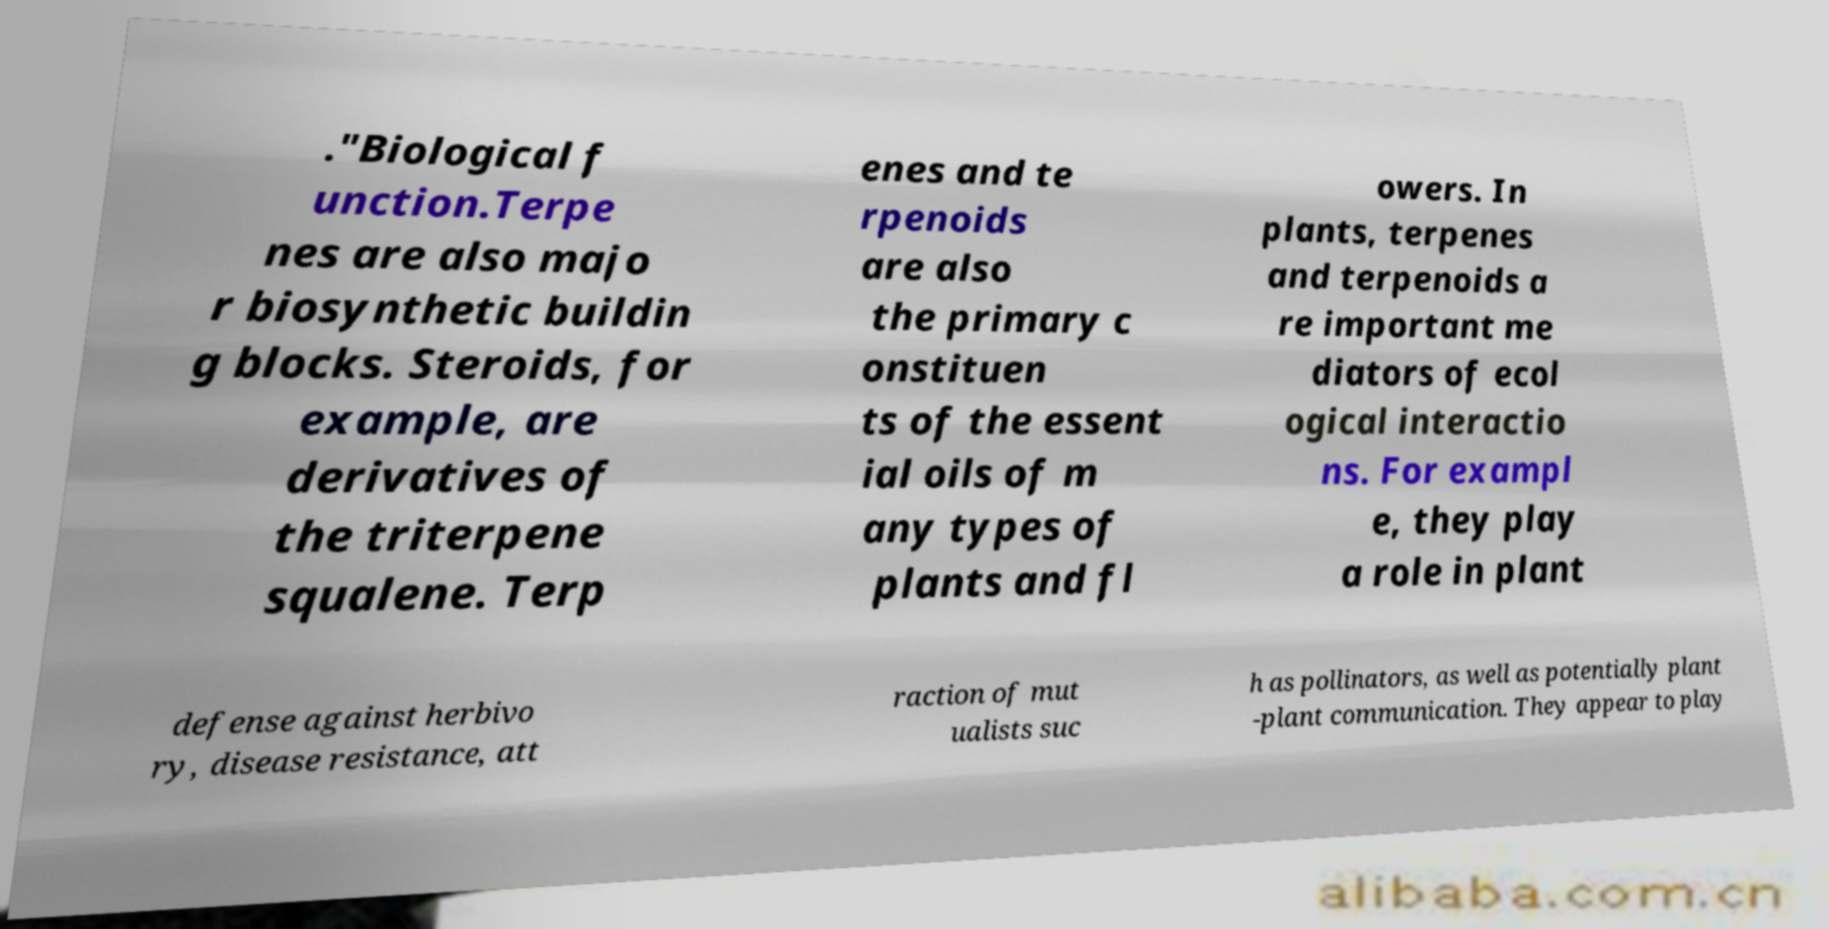Can you read and provide the text displayed in the image?This photo seems to have some interesting text. Can you extract and type it out for me? ."Biological f unction.Terpe nes are also majo r biosynthetic buildin g blocks. Steroids, for example, are derivatives of the triterpene squalene. Terp enes and te rpenoids are also the primary c onstituen ts of the essent ial oils of m any types of plants and fl owers. In plants, terpenes and terpenoids a re important me diators of ecol ogical interactio ns. For exampl e, they play a role in plant defense against herbivo ry, disease resistance, att raction of mut ualists suc h as pollinators, as well as potentially plant -plant communication. They appear to play 